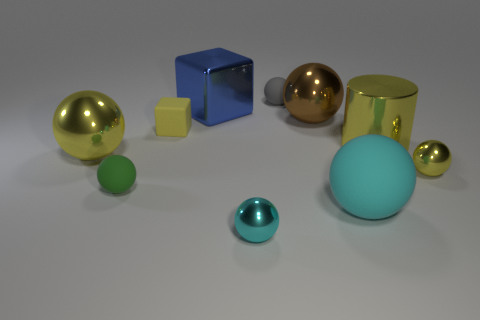There is a matte thing that is in front of the small gray sphere and behind the tiny green sphere; what shape is it?
Your response must be concise. Cube. What number of blue things are either large rubber objects or small matte blocks?
Your answer should be very brief. 0. There is a tiny sphere left of the big blue block; is its color the same as the rubber cube?
Make the answer very short. No. What size is the thing that is on the right side of the big yellow metal thing that is on the right side of the small gray matte object?
Give a very brief answer. Small. What material is the yellow cube that is the same size as the cyan shiny object?
Your answer should be compact. Rubber. What number of other things are the same size as the cyan rubber ball?
Your answer should be very brief. 4. How many balls are yellow metallic things or small gray matte objects?
Give a very brief answer. 3. Is there any other thing that is the same material as the yellow cube?
Keep it short and to the point. Yes. What is the cyan object that is to the left of the small matte ball that is behind the large metallic sphere left of the yellow matte thing made of?
Give a very brief answer. Metal. There is a large cylinder that is the same color as the small rubber block; what material is it?
Your response must be concise. Metal. 